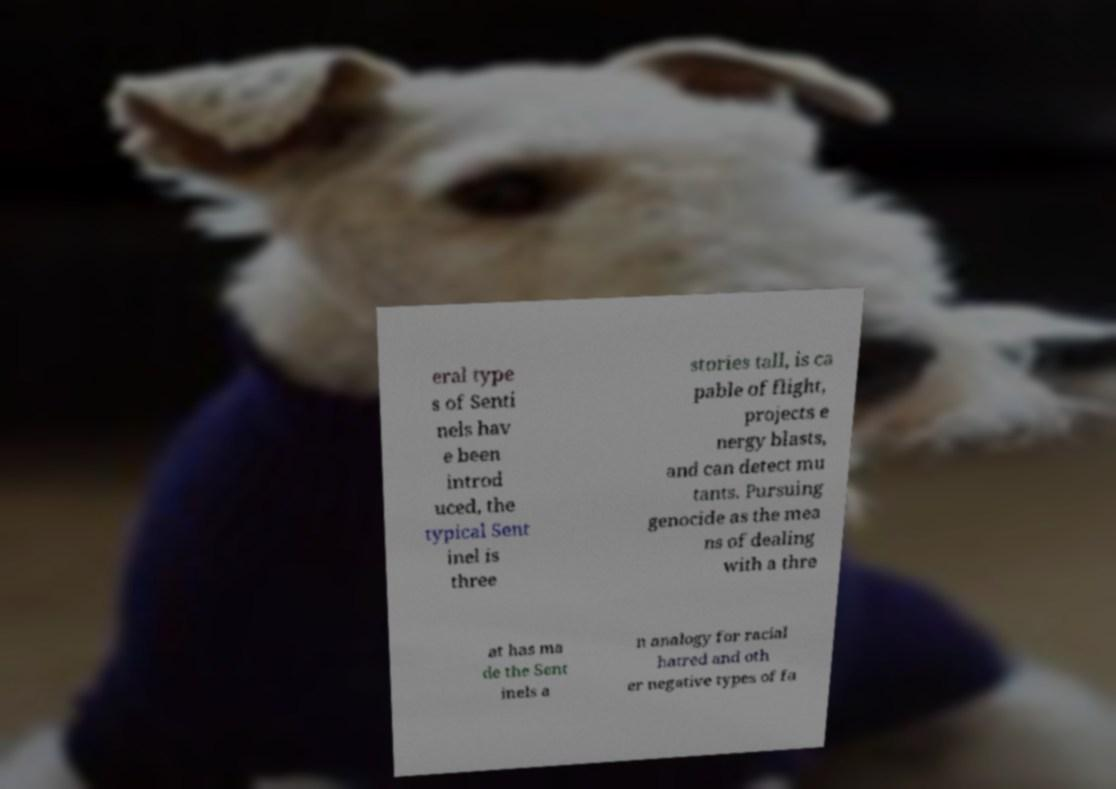What messages or text are displayed in this image? I need them in a readable, typed format. eral type s of Senti nels hav e been introd uced, the typical Sent inel is three stories tall, is ca pable of flight, projects e nergy blasts, and can detect mu tants. Pursuing genocide as the mea ns of dealing with a thre at has ma de the Sent inels a n analogy for racial hatred and oth er negative types of fa 